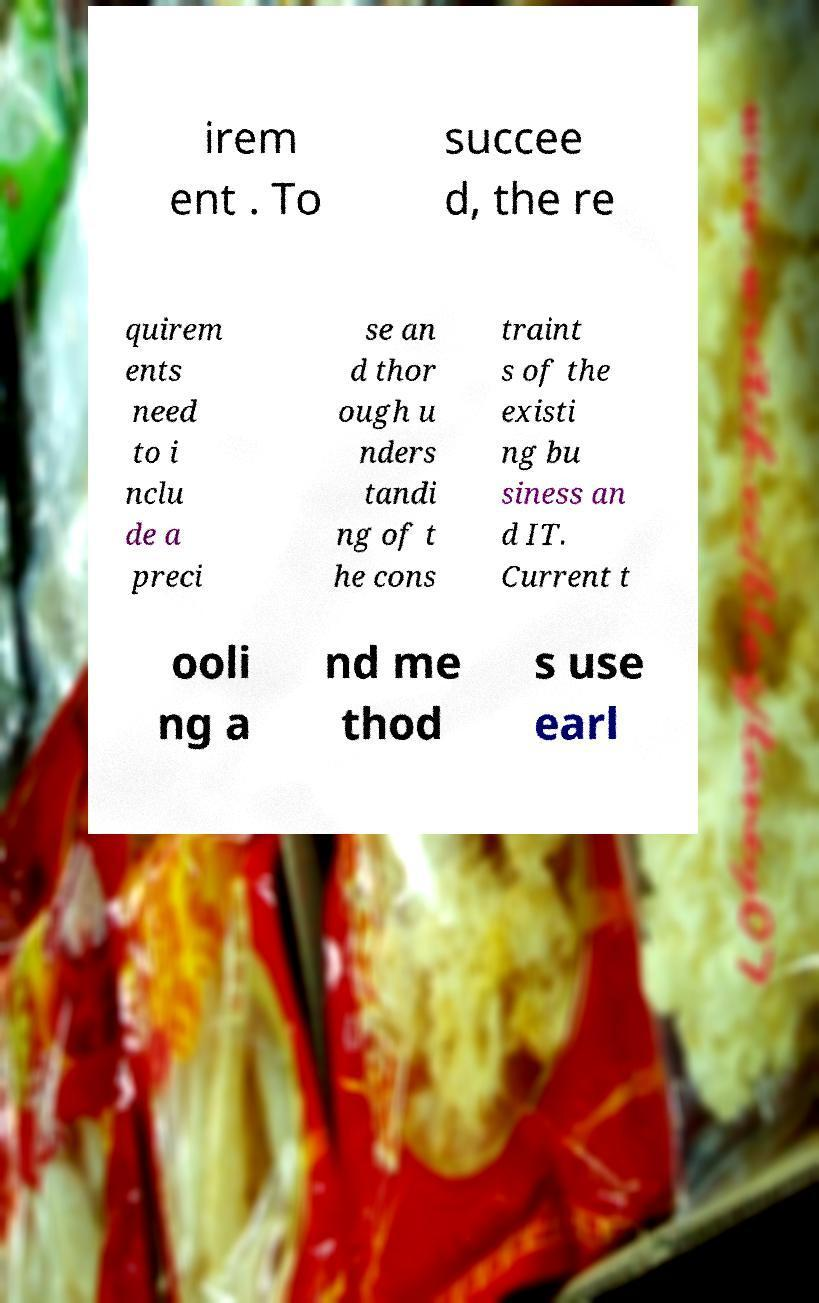What messages or text are displayed in this image? I need them in a readable, typed format. irem ent . To succee d, the re quirem ents need to i nclu de a preci se an d thor ough u nders tandi ng of t he cons traint s of the existi ng bu siness an d IT. Current t ooli ng a nd me thod s use earl 